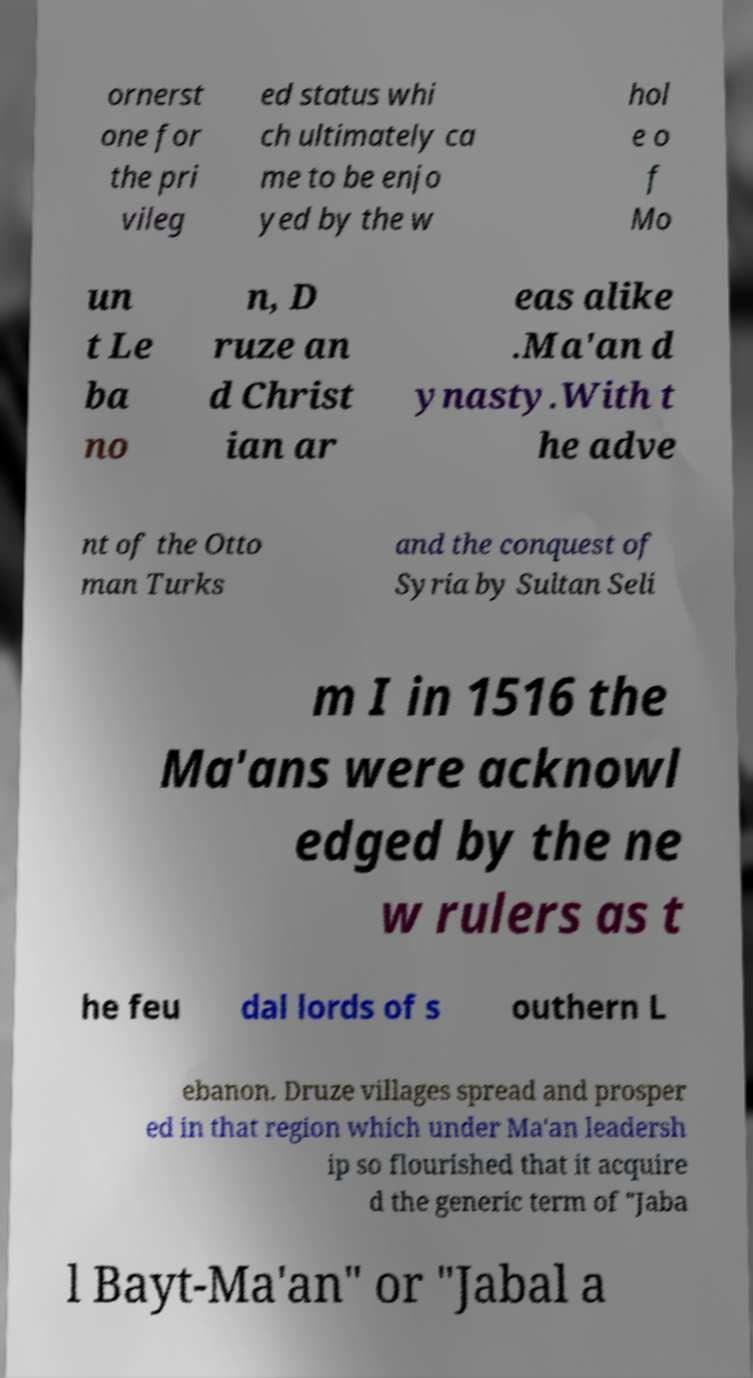What messages or text are displayed in this image? I need them in a readable, typed format. ornerst one for the pri vileg ed status whi ch ultimately ca me to be enjo yed by the w hol e o f Mo un t Le ba no n, D ruze an d Christ ian ar eas alike .Ma'an d ynasty.With t he adve nt of the Otto man Turks and the conquest of Syria by Sultan Seli m I in 1516 the Ma'ans were acknowl edged by the ne w rulers as t he feu dal lords of s outhern L ebanon. Druze villages spread and prosper ed in that region which under Ma'an leadersh ip so flourished that it acquire d the generic term of "Jaba l Bayt-Ma'an" or "Jabal a 